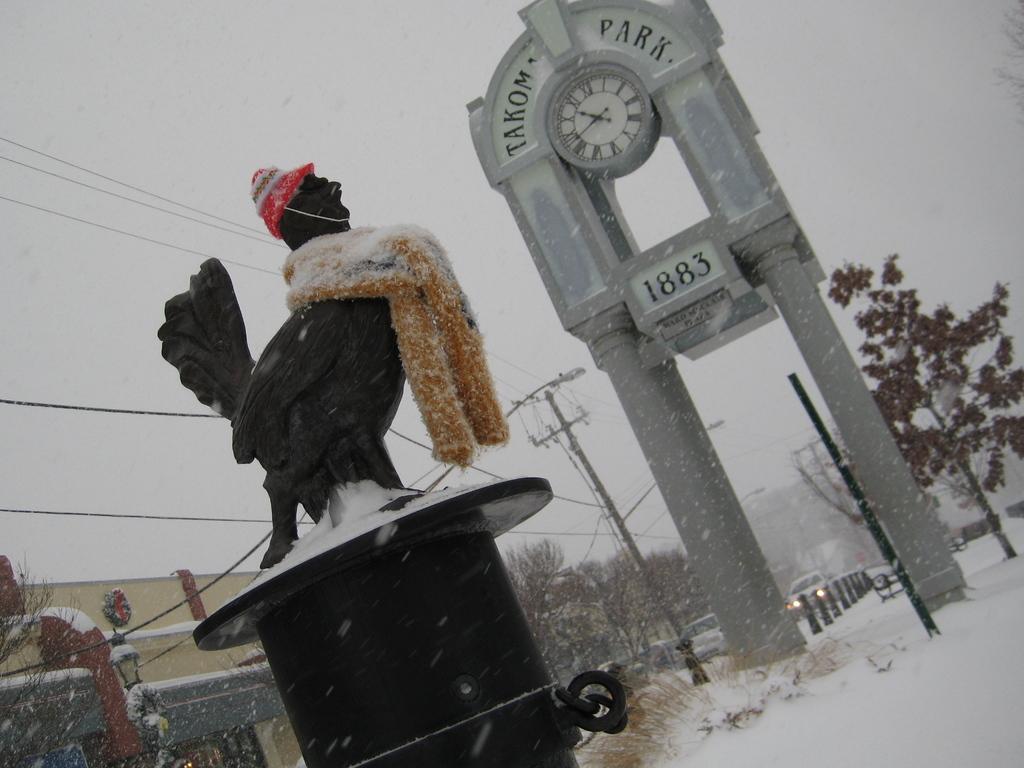Can you describe this image briefly? In this image I can see a black colour thing in the front and on it I can see few clothes. In the background I can see snow, number of trees, few poles, few wires and few vehicles. On the top of this image I can see a clock and I can also see something is written above and below the clock. On the left side of this image I can see a building. 